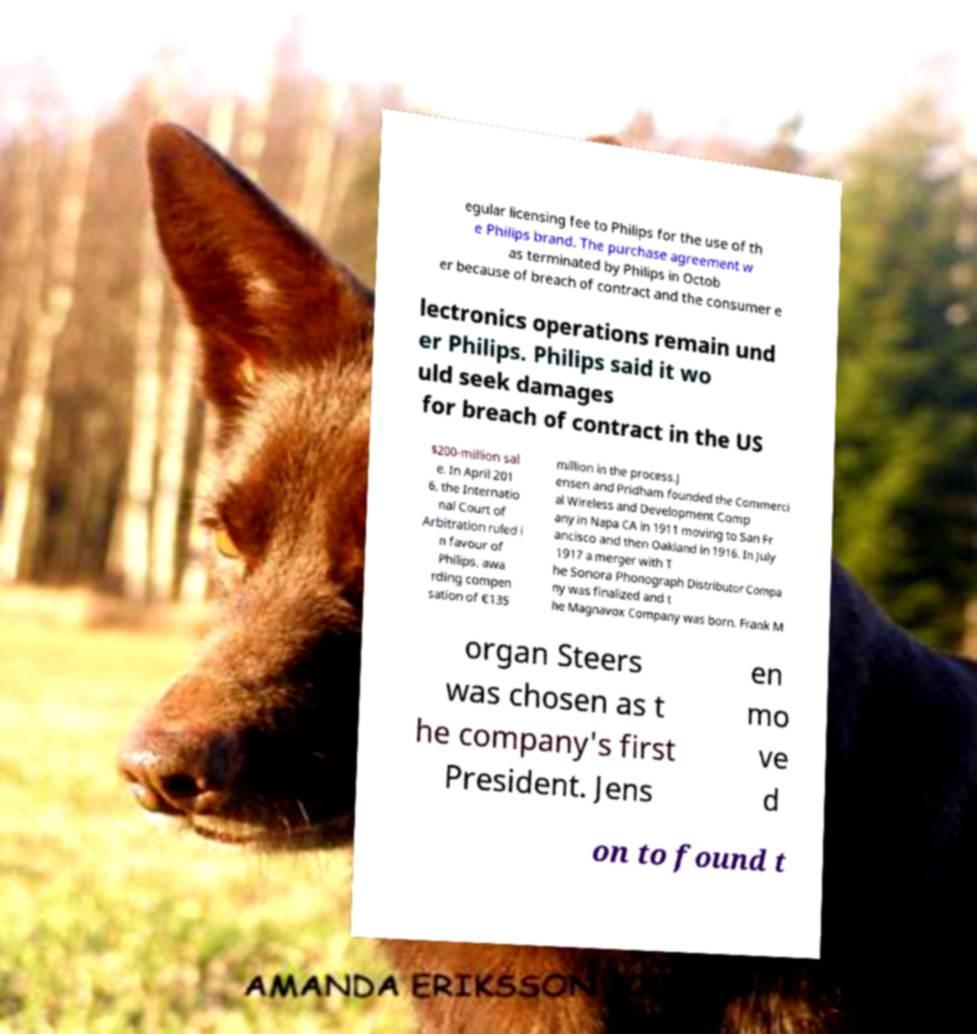What messages or text are displayed in this image? I need them in a readable, typed format. egular licensing fee to Philips for the use of th e Philips brand. The purchase agreement w as terminated by Philips in Octob er because of breach of contract and the consumer e lectronics operations remain und er Philips. Philips said it wo uld seek damages for breach of contract in the US $200-million sal e. In April 201 6, the Internatio nal Court of Arbitration ruled i n favour of Philips, awa rding compen sation of €135 million in the process.J ensen and Pridham founded the Commerci al Wireless and Development Comp any in Napa CA in 1911 moving to San Fr ancisco and then Oakland in 1916. In July 1917 a merger with T he Sonora Phonograph Distributor Compa ny was finalized and t he Magnavox Company was born. Frank M organ Steers was chosen as t he company's first President. Jens en mo ve d on to found t 